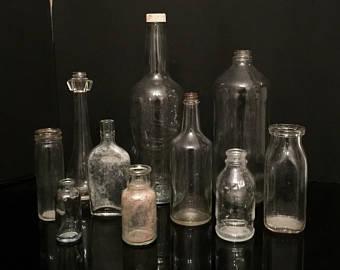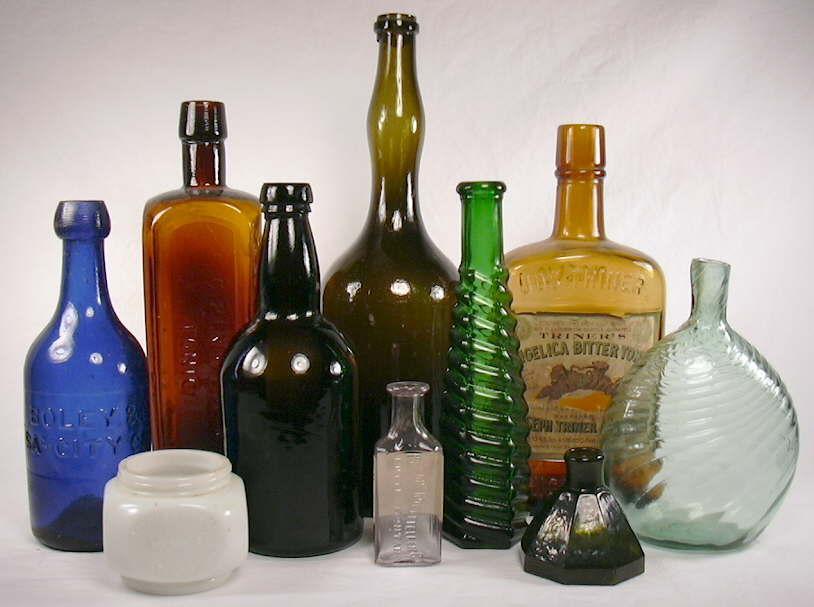The first image is the image on the left, the second image is the image on the right. Analyze the images presented: Is the assertion "One image features only upright bottles in a variety of shapes, sizes and colors, and includes at least one bottle with a paper label." valid? Answer yes or no. Yes. The first image is the image on the left, the second image is the image on the right. Assess this claim about the two images: "There is a blue bottle in both images.". Correct or not? Answer yes or no. No. 